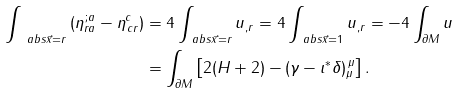<formula> <loc_0><loc_0><loc_500><loc_500>\int _ { \ a b s { \vec { x } } = r } \left ( \eta _ { r a } ^ { \, ; a } - \eta ^ { c } _ { \, c r } \right ) & = 4 \int _ { \ a b s { \vec { x } } = r } u _ { , r } = 4 \int _ { \ a b s { \vec { x } } = 1 } u _ { , r } = - 4 \int _ { \partial M } u \\ & = \int _ { \partial M } \left [ 2 ( H + 2 ) - ( \gamma - \iota ^ { * } \delta ) _ { \mu } ^ { \, \mu } \right ] .</formula> 